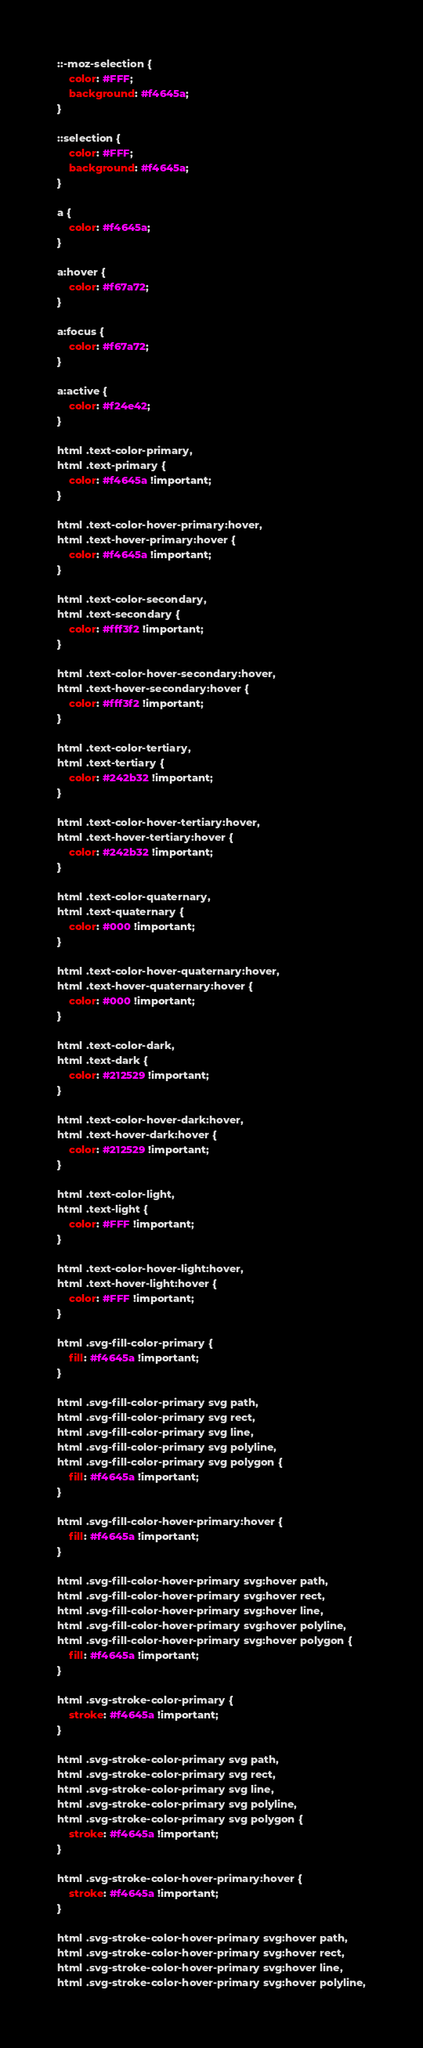Convert code to text. <code><loc_0><loc_0><loc_500><loc_500><_CSS_>::-moz-selection {
	color: #FFF;
	background: #f4645a;
}

::selection {
	color: #FFF;
	background: #f4645a;
}

a {
	color: #f4645a;
}

a:hover {
	color: #f67a72;
}

a:focus {
	color: #f67a72;
}

a:active {
	color: #f24e42;
}

html .text-color-primary,
html .text-primary {
	color: #f4645a !important;
}

html .text-color-hover-primary:hover,
html .text-hover-primary:hover {
	color: #f4645a !important;
}

html .text-color-secondary,
html .text-secondary {
	color: #fff3f2 !important;
}

html .text-color-hover-secondary:hover,
html .text-hover-secondary:hover {
	color: #fff3f2 !important;
}

html .text-color-tertiary,
html .text-tertiary {
	color: #242b32 !important;
}

html .text-color-hover-tertiary:hover,
html .text-hover-tertiary:hover {
	color: #242b32 !important;
}

html .text-color-quaternary,
html .text-quaternary {
	color: #000 !important;
}

html .text-color-hover-quaternary:hover,
html .text-hover-quaternary:hover {
	color: #000 !important;
}

html .text-color-dark,
html .text-dark {
	color: #212529 !important;
}

html .text-color-hover-dark:hover,
html .text-hover-dark:hover {
	color: #212529 !important;
}

html .text-color-light,
html .text-light {
	color: #FFF !important;
}

html .text-color-hover-light:hover,
html .text-hover-light:hover {
	color: #FFF !important;
}

html .svg-fill-color-primary {
	fill: #f4645a !important;
}

html .svg-fill-color-primary svg path,
html .svg-fill-color-primary svg rect,
html .svg-fill-color-primary svg line,
html .svg-fill-color-primary svg polyline,
html .svg-fill-color-primary svg polygon {
	fill: #f4645a !important;
}

html .svg-fill-color-hover-primary:hover {
	fill: #f4645a !important;
}

html .svg-fill-color-hover-primary svg:hover path,
html .svg-fill-color-hover-primary svg:hover rect,
html .svg-fill-color-hover-primary svg:hover line,
html .svg-fill-color-hover-primary svg:hover polyline,
html .svg-fill-color-hover-primary svg:hover polygon {
	fill: #f4645a !important;
}

html .svg-stroke-color-primary {
	stroke: #f4645a !important;
}

html .svg-stroke-color-primary svg path,
html .svg-stroke-color-primary svg rect,
html .svg-stroke-color-primary svg line,
html .svg-stroke-color-primary svg polyline,
html .svg-stroke-color-primary svg polygon {
	stroke: #f4645a !important;
}

html .svg-stroke-color-hover-primary:hover {
	stroke: #f4645a !important;
}

html .svg-stroke-color-hover-primary svg:hover path,
html .svg-stroke-color-hover-primary svg:hover rect,
html .svg-stroke-color-hover-primary svg:hover line,
html .svg-stroke-color-hover-primary svg:hover polyline,</code> 